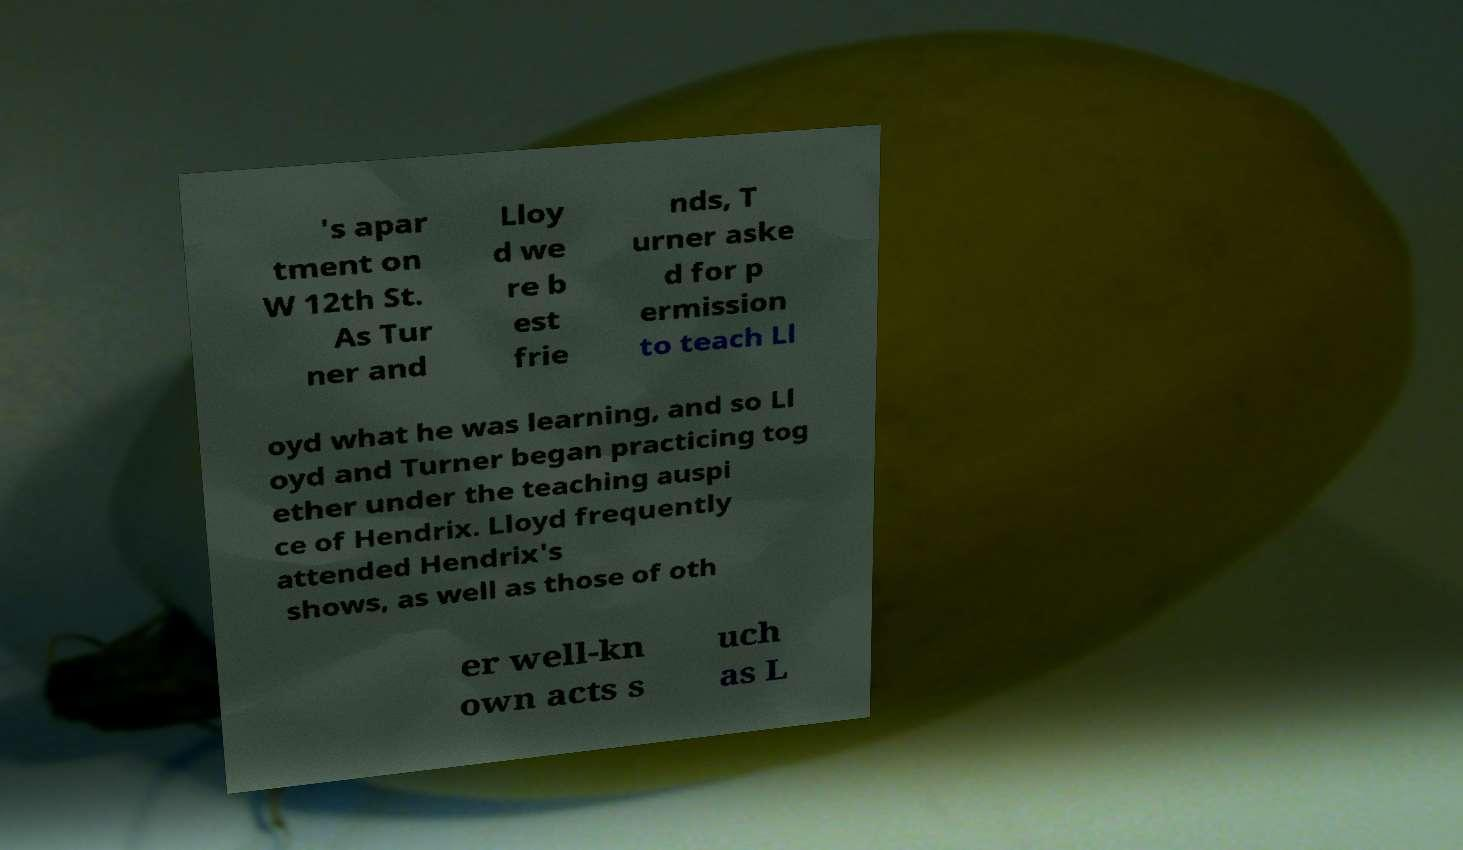Could you assist in decoding the text presented in this image and type it out clearly? 's apar tment on W 12th St. As Tur ner and Lloy d we re b est frie nds, T urner aske d for p ermission to teach Ll oyd what he was learning, and so Ll oyd and Turner began practicing tog ether under the teaching auspi ce of Hendrix. Lloyd frequently attended Hendrix's shows, as well as those of oth er well-kn own acts s uch as L 